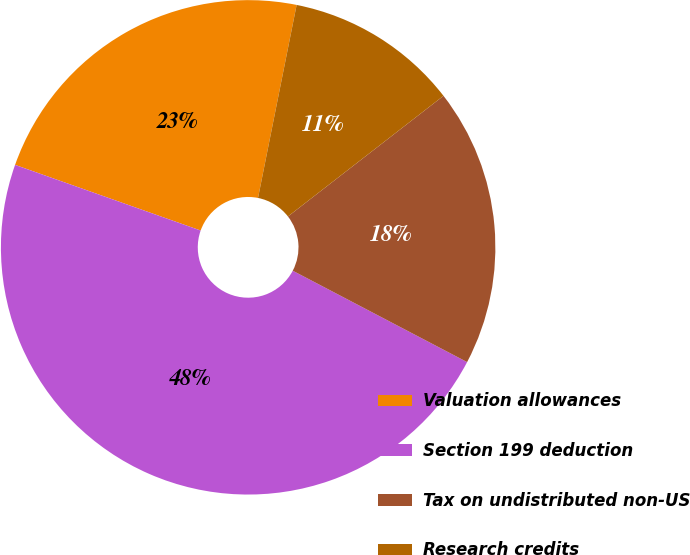Convert chart to OTSL. <chart><loc_0><loc_0><loc_500><loc_500><pie_chart><fcel>Valuation allowances<fcel>Section 199 deduction<fcel>Tax on undistributed non-US<fcel>Research credits<nl><fcel>22.73%<fcel>47.73%<fcel>18.18%<fcel>11.36%<nl></chart> 